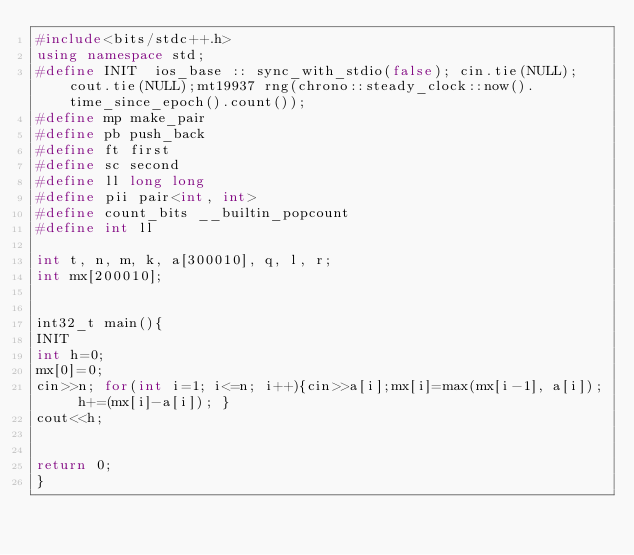Convert code to text. <code><loc_0><loc_0><loc_500><loc_500><_C++_>#include<bits/stdc++.h>
using namespace std;
#define INIT  ios_base :: sync_with_stdio(false); cin.tie(NULL); cout.tie(NULL);mt19937 rng(chrono::steady_clock::now().time_since_epoch().count());
#define mp make_pair
#define pb push_back
#define ft first
#define sc second
#define ll long long
#define pii pair<int, int>
#define count_bits __builtin_popcount
#define int ll

int t, n, m, k, a[300010], q, l, r;
int mx[200010];


int32_t main(){
INIT
int h=0;
mx[0]=0;
cin>>n; for(int i=1; i<=n; i++){cin>>a[i];mx[i]=max(mx[i-1], a[i]); h+=(mx[i]-a[i]); }
cout<<h;


return 0;
}



</code> 